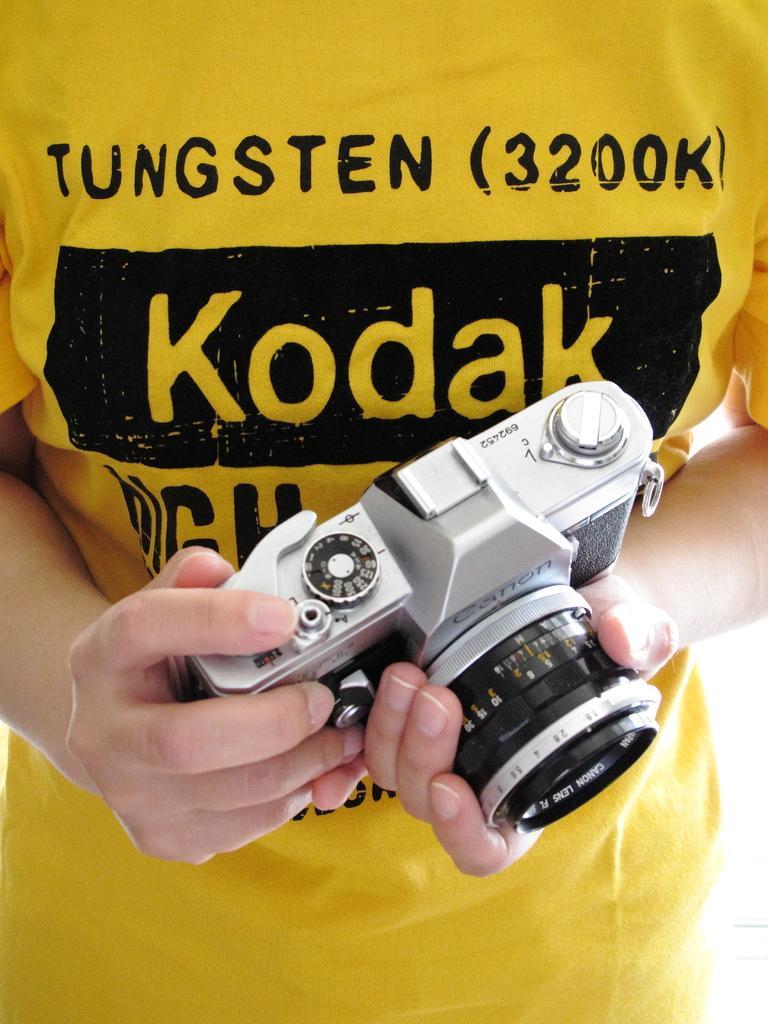How would you summarize this image in a sentence or two? In this image we can see camera in person's hand. 